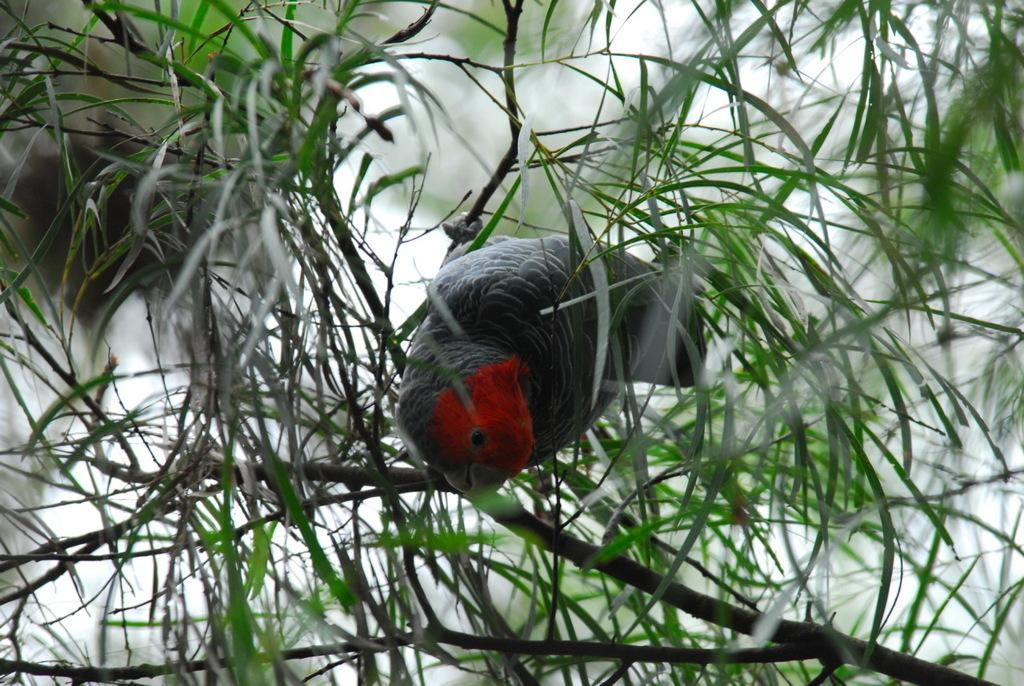What type of animal is present in the image? There is a bird in the image. Where is the bird located? The bird is on a plant. What can be seen in the background of the image? There are green leaves in the image. What type of education does the bird have in the image? There is no indication of the bird's education in the image. Is the bird experiencing a crush on another bird in the image? There is no indication of the bird's emotions or relationships in the image. 